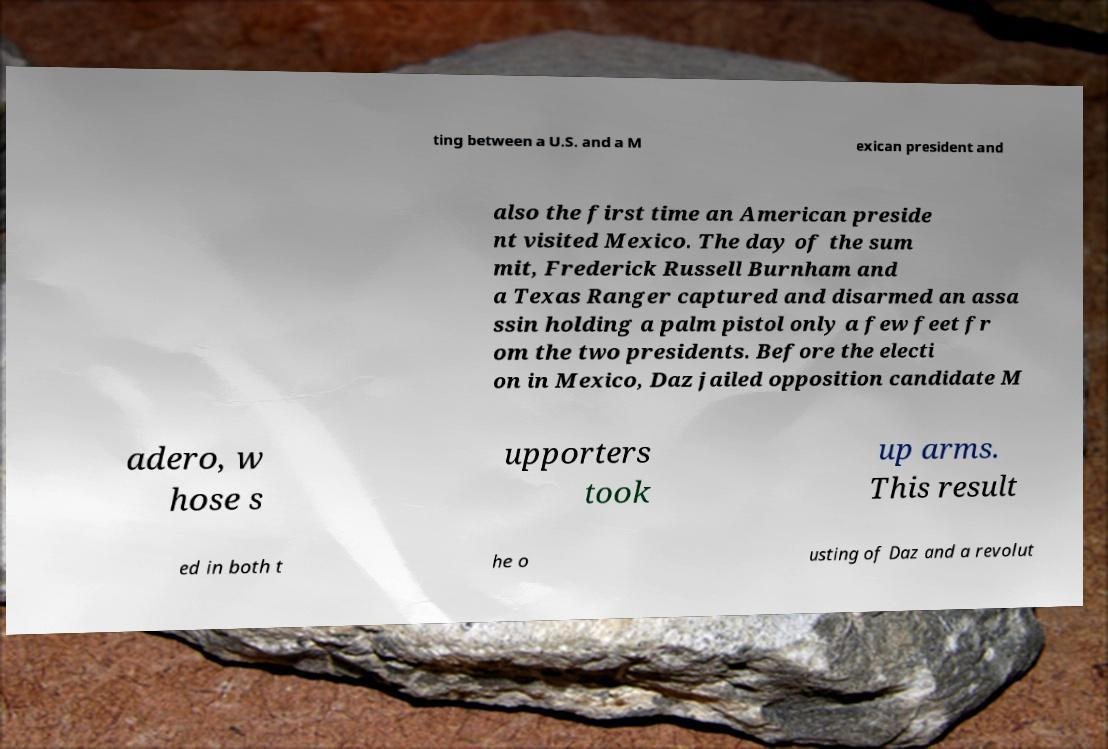I need the written content from this picture converted into text. Can you do that? ting between a U.S. and a M exican president and also the first time an American preside nt visited Mexico. The day of the sum mit, Frederick Russell Burnham and a Texas Ranger captured and disarmed an assa ssin holding a palm pistol only a few feet fr om the two presidents. Before the electi on in Mexico, Daz jailed opposition candidate M adero, w hose s upporters took up arms. This result ed in both t he o usting of Daz and a revolut 